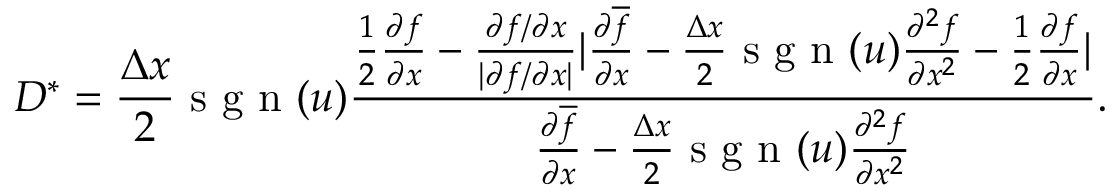<formula> <loc_0><loc_0><loc_500><loc_500>D ^ { \ast } = \frac { \Delta x } { 2 } s g n ( u ) \frac { \frac { 1 } { 2 } \frac { \partial f } { \partial x } - \frac { \partial f / \partial x } { | \partial f / \partial x | } | \frac { \partial \overline { f } } { \partial x } - \frac { \Delta x } { 2 } s g n ( u ) \frac { \partial ^ { 2 } f } { \partial x ^ { 2 } } - \frac { 1 } { 2 } \frac { \partial f } { \partial x } | } { \frac { \partial \overline { f } } { \partial x } - \frac { \Delta x } { 2 } s g n ( u ) \frac { \partial ^ { 2 } f } { \partial x ^ { 2 } } } .</formula> 